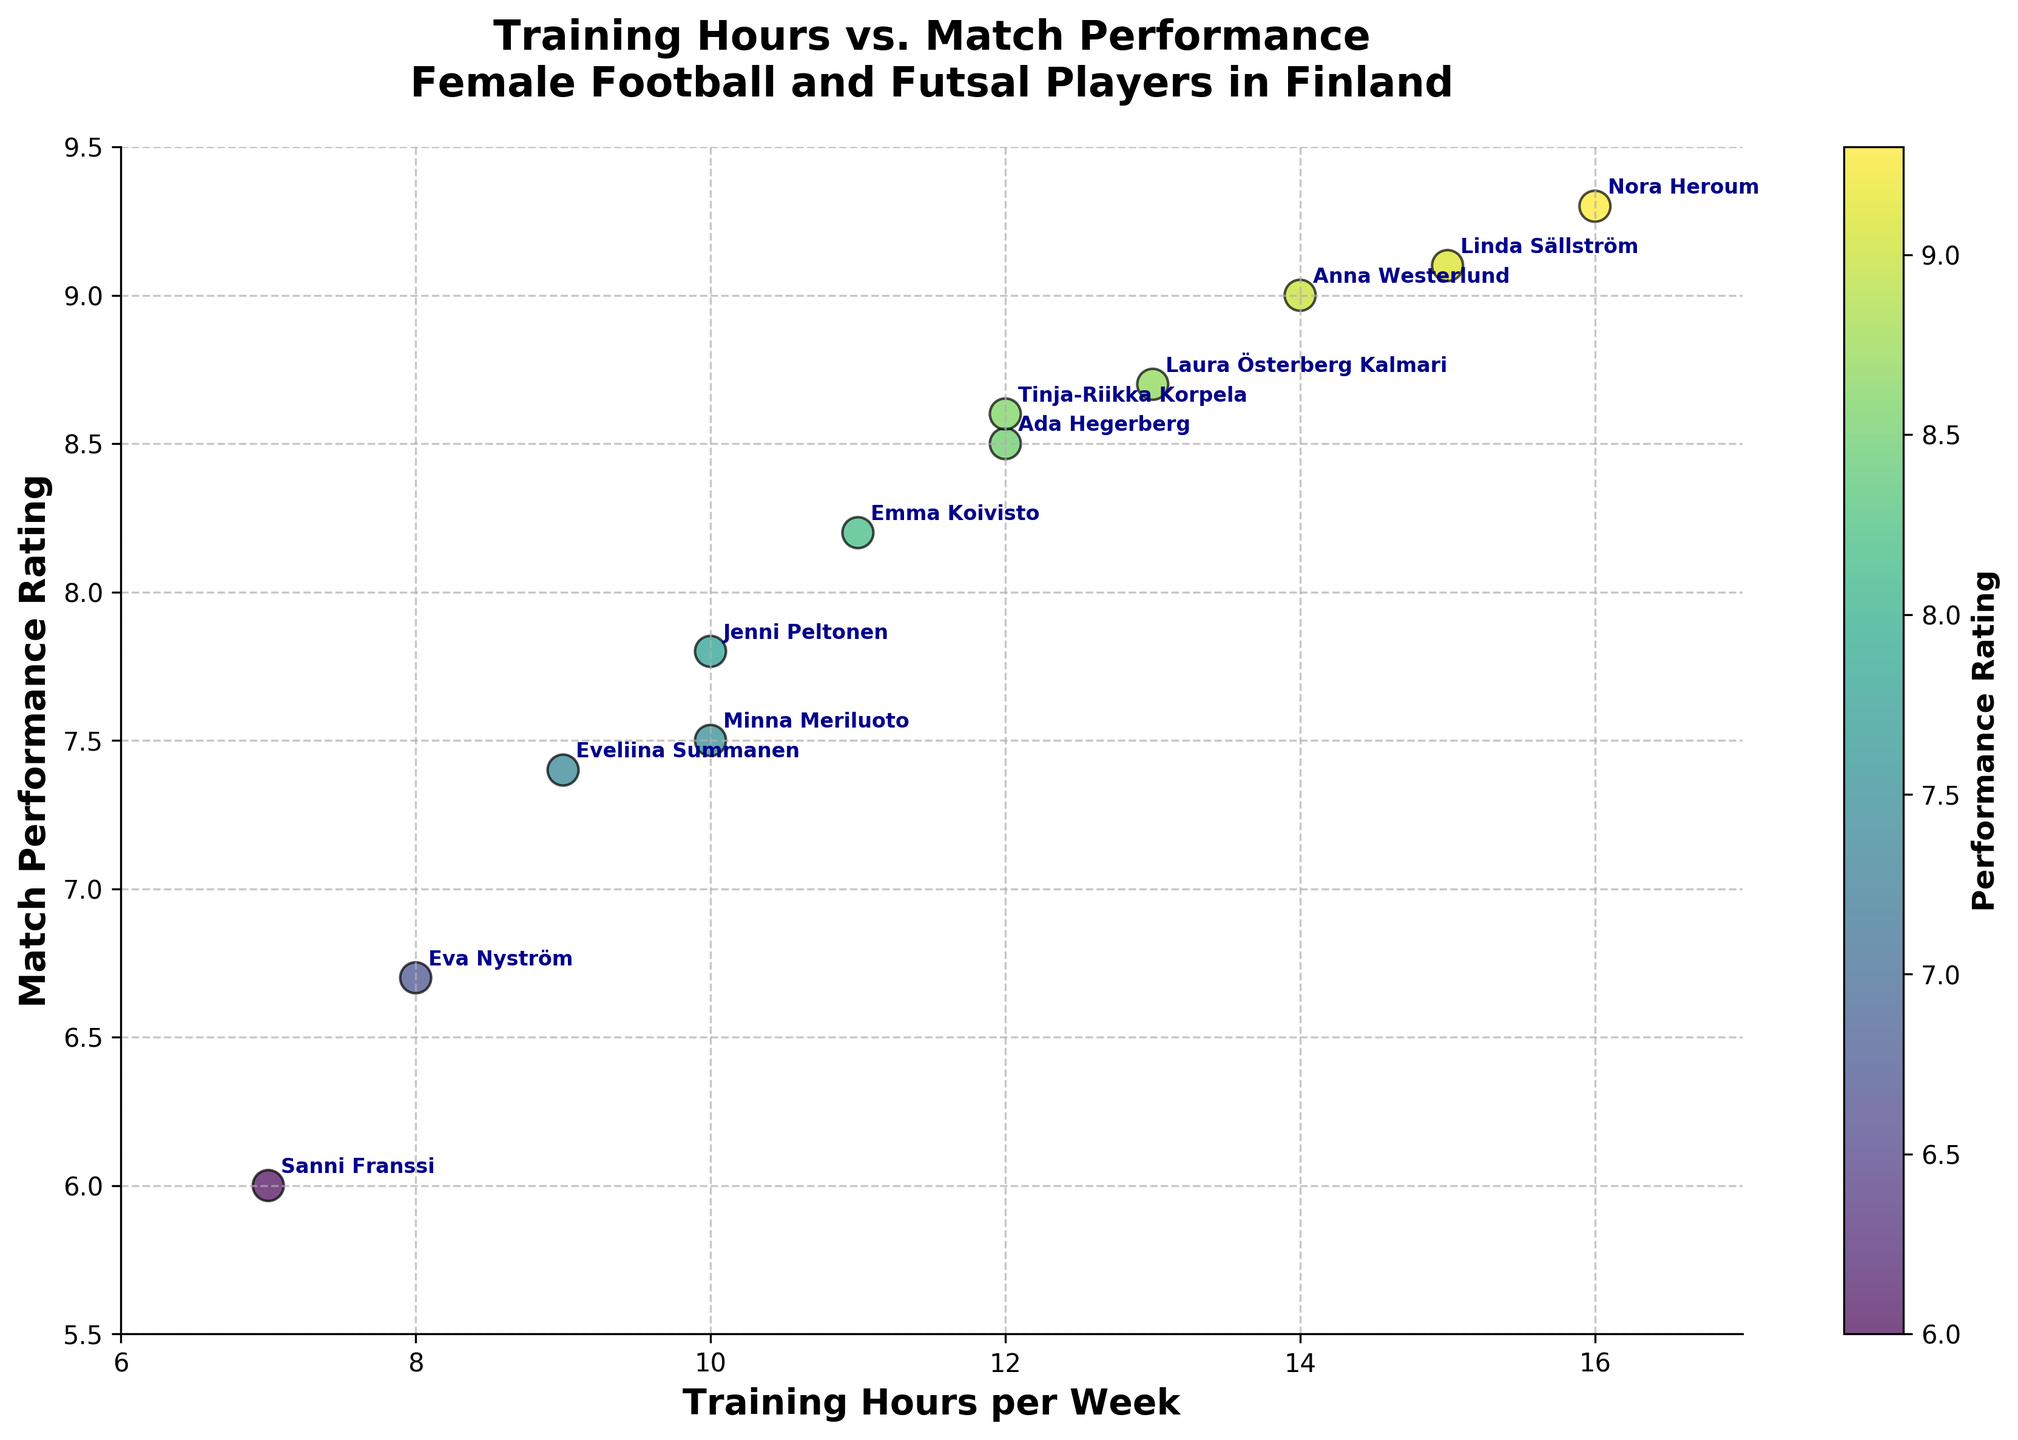How many players are plotted in the scatter plot? Count the number of data points represented by the players' names in the plot. There are 12 players named.
Answer: 12 What does the color represent in the scatter plot? The color indicates the match performance rating, as noted by the color bar on the right side of the plot.
Answer: Match performance rating Which player trains the most hours per week? Identify the player at the highest value on the x-axis, which represents training hours per week. Nora Heroum is at 16 hours per week.
Answer: Nora Heroum What is the match performance rating of Laura Österberg Kalmari? Look for Laura Österberg Kalmari in the scatter plot and read the corresponding y-axis value.
Answer: 8.7 Who has a higher match performance rating, Anna Westerlund or Tinja-Riikka Korpela? Compare the y-axis values of Anna Westerlund and Tinja-Riikka Korpela in the scatter plot. Anna Westerlund is rated 9.0, while Tinja-Riikka Korpela is rated 8.6.
Answer: Anna Westerlund What is the average training hours per week for players with a match performance rating above 9? Identify the players with match performance ratings above 9 (Linda Sällström, Anna Westerlund, Nora Heroum), sum their training hours (15, 14, 16), and then divide by the number of players (3). (15+14+16) / 3 = 45/3
Answer: 15 What's the difference in match performance ratings between the top performer and the lowest performer? Top performer Nora Heroum has a rating of 9.3, and the lowest performer Sanni Franssi has a rating of 6.0. Calculate the difference 9.3 - 6.0.
Answer: 3.3 Which player has the closest match performance rating to 8.0? Find the player whose match performance rating is nearest to 8.0 by comparing the y-axis values from the plot. Jenni Peltonen has a rating of 7.8, which is closest.
Answer: Jenni Peltonen Is there an observable trend between training hours and match performance? Look at the general direction in which the data points are scattered. Most higher match performance ratings seem to occur with higher training hours, indicating a positive correlation.
Answer: Positive correlation How many players have training hours of 10 or more per week? Count the number of players who fall at or beyond the 10-hour mark on the x-axis. There are 8 players (Minna Meriluoto, Jenni Peltonen, Tinja-Riikka Korpela, Laura Österberg Kalmari, Emma Koivisto, Ada Hegerberg, Anna Westerlund, Linda Sällström).
Answer: 8 